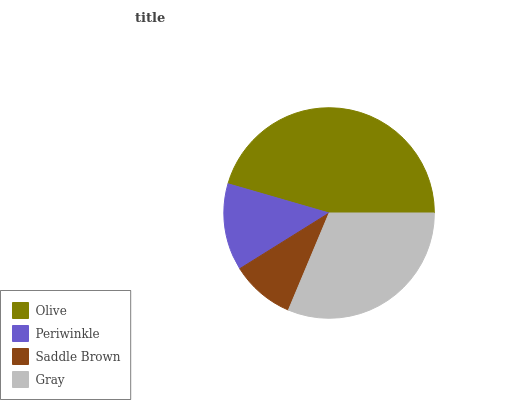Is Saddle Brown the minimum?
Answer yes or no. Yes. Is Olive the maximum?
Answer yes or no. Yes. Is Periwinkle the minimum?
Answer yes or no. No. Is Periwinkle the maximum?
Answer yes or no. No. Is Olive greater than Periwinkle?
Answer yes or no. Yes. Is Periwinkle less than Olive?
Answer yes or no. Yes. Is Periwinkle greater than Olive?
Answer yes or no. No. Is Olive less than Periwinkle?
Answer yes or no. No. Is Gray the high median?
Answer yes or no. Yes. Is Periwinkle the low median?
Answer yes or no. Yes. Is Olive the high median?
Answer yes or no. No. Is Gray the low median?
Answer yes or no. No. 